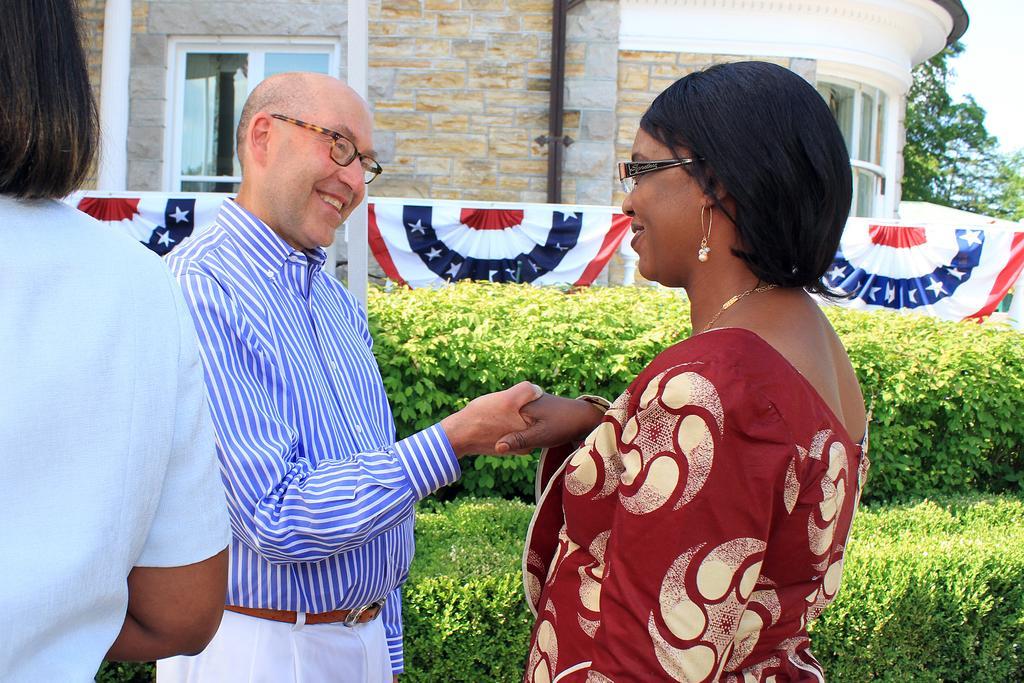Could you give a brief overview of what you see in this image? In this image we can see a house and it is having a window. There are three persons in the image. There are many plants in the image. There is a sky in the image. 